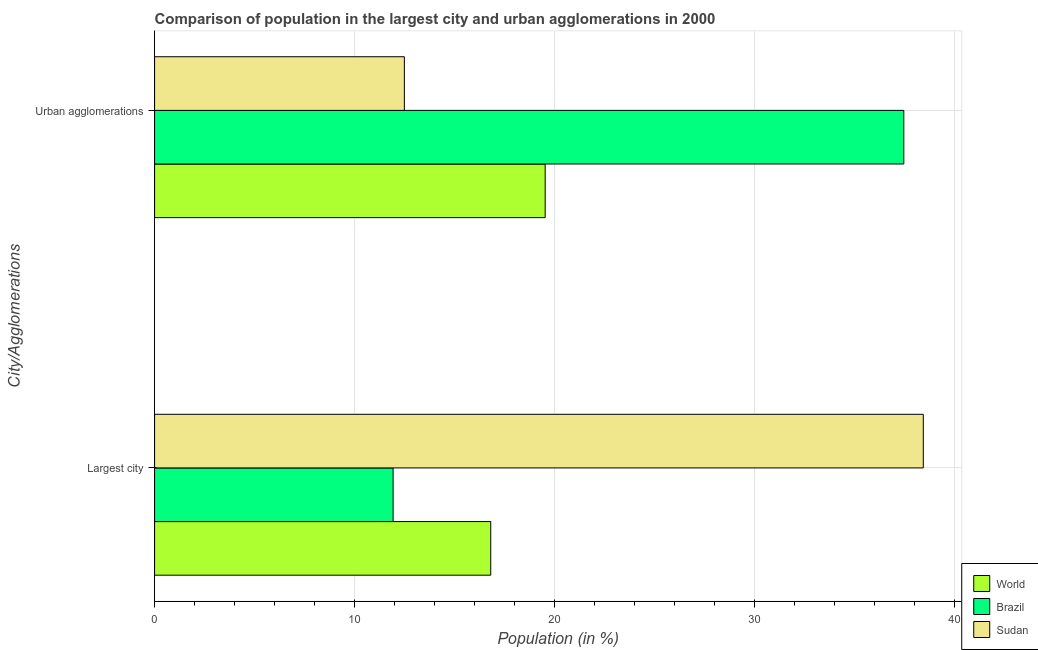How many different coloured bars are there?
Offer a terse response. 3. How many groups of bars are there?
Provide a succinct answer. 2. How many bars are there on the 2nd tick from the top?
Keep it short and to the point. 3. What is the label of the 1st group of bars from the top?
Ensure brevity in your answer.  Urban agglomerations. What is the population in the largest city in Sudan?
Provide a succinct answer. 38.42. Across all countries, what is the maximum population in the largest city?
Your response must be concise. 38.42. Across all countries, what is the minimum population in urban agglomerations?
Provide a short and direct response. 12.48. In which country was the population in urban agglomerations maximum?
Your answer should be compact. Brazil. In which country was the population in urban agglomerations minimum?
Your response must be concise. Sudan. What is the total population in the largest city in the graph?
Make the answer very short. 67.14. What is the difference between the population in urban agglomerations in Sudan and that in Brazil?
Offer a terse response. -24.96. What is the difference between the population in urban agglomerations in Sudan and the population in the largest city in World?
Make the answer very short. -4.32. What is the average population in urban agglomerations per country?
Offer a terse response. 23.15. What is the difference between the population in urban agglomerations and population in the largest city in Brazil?
Offer a terse response. 25.52. What is the ratio of the population in urban agglomerations in Sudan to that in World?
Make the answer very short. 0.64. In how many countries, is the population in urban agglomerations greater than the average population in urban agglomerations taken over all countries?
Your answer should be compact. 1. What does the 1st bar from the top in Urban agglomerations represents?
Your answer should be compact. Sudan. Are all the bars in the graph horizontal?
Your answer should be compact. Yes. What is the difference between two consecutive major ticks on the X-axis?
Provide a succinct answer. 10. Are the values on the major ticks of X-axis written in scientific E-notation?
Your answer should be very brief. No. Does the graph contain any zero values?
Give a very brief answer. No. Where does the legend appear in the graph?
Your response must be concise. Bottom right. How many legend labels are there?
Ensure brevity in your answer.  3. What is the title of the graph?
Offer a terse response. Comparison of population in the largest city and urban agglomerations in 2000. Does "Afghanistan" appear as one of the legend labels in the graph?
Offer a terse response. No. What is the label or title of the X-axis?
Ensure brevity in your answer.  Population (in %). What is the label or title of the Y-axis?
Offer a very short reply. City/Agglomerations. What is the Population (in %) in World in Largest city?
Provide a short and direct response. 16.8. What is the Population (in %) in Brazil in Largest city?
Give a very brief answer. 11.92. What is the Population (in %) in Sudan in Largest city?
Make the answer very short. 38.42. What is the Population (in %) in World in Urban agglomerations?
Your response must be concise. 19.52. What is the Population (in %) of Brazil in Urban agglomerations?
Provide a short and direct response. 37.44. What is the Population (in %) of Sudan in Urban agglomerations?
Your response must be concise. 12.48. Across all City/Agglomerations, what is the maximum Population (in %) of World?
Give a very brief answer. 19.52. Across all City/Agglomerations, what is the maximum Population (in %) of Brazil?
Provide a succinct answer. 37.44. Across all City/Agglomerations, what is the maximum Population (in %) in Sudan?
Your response must be concise. 38.42. Across all City/Agglomerations, what is the minimum Population (in %) of World?
Ensure brevity in your answer.  16.8. Across all City/Agglomerations, what is the minimum Population (in %) of Brazil?
Ensure brevity in your answer.  11.92. Across all City/Agglomerations, what is the minimum Population (in %) of Sudan?
Keep it short and to the point. 12.48. What is the total Population (in %) of World in the graph?
Offer a very short reply. 36.32. What is the total Population (in %) of Brazil in the graph?
Your response must be concise. 49.37. What is the total Population (in %) in Sudan in the graph?
Give a very brief answer. 50.9. What is the difference between the Population (in %) in World in Largest city and that in Urban agglomerations?
Keep it short and to the point. -2.72. What is the difference between the Population (in %) of Brazil in Largest city and that in Urban agglomerations?
Make the answer very short. -25.52. What is the difference between the Population (in %) of Sudan in Largest city and that in Urban agglomerations?
Offer a very short reply. 25.93. What is the difference between the Population (in %) of World in Largest city and the Population (in %) of Brazil in Urban agglomerations?
Offer a terse response. -20.64. What is the difference between the Population (in %) of World in Largest city and the Population (in %) of Sudan in Urban agglomerations?
Keep it short and to the point. 4.32. What is the difference between the Population (in %) in Brazil in Largest city and the Population (in %) in Sudan in Urban agglomerations?
Your answer should be very brief. -0.56. What is the average Population (in %) in World per City/Agglomerations?
Ensure brevity in your answer.  18.16. What is the average Population (in %) in Brazil per City/Agglomerations?
Keep it short and to the point. 24.68. What is the average Population (in %) in Sudan per City/Agglomerations?
Give a very brief answer. 25.45. What is the difference between the Population (in %) of World and Population (in %) of Brazil in Largest city?
Your answer should be very brief. 4.88. What is the difference between the Population (in %) in World and Population (in %) in Sudan in Largest city?
Offer a very short reply. -21.62. What is the difference between the Population (in %) of Brazil and Population (in %) of Sudan in Largest city?
Give a very brief answer. -26.5. What is the difference between the Population (in %) of World and Population (in %) of Brazil in Urban agglomerations?
Give a very brief answer. -17.92. What is the difference between the Population (in %) of World and Population (in %) of Sudan in Urban agglomerations?
Keep it short and to the point. 7.04. What is the difference between the Population (in %) of Brazil and Population (in %) of Sudan in Urban agglomerations?
Your answer should be very brief. 24.96. What is the ratio of the Population (in %) in World in Largest city to that in Urban agglomerations?
Give a very brief answer. 0.86. What is the ratio of the Population (in %) in Brazil in Largest city to that in Urban agglomerations?
Make the answer very short. 0.32. What is the ratio of the Population (in %) in Sudan in Largest city to that in Urban agglomerations?
Offer a terse response. 3.08. What is the difference between the highest and the second highest Population (in %) in World?
Your answer should be compact. 2.72. What is the difference between the highest and the second highest Population (in %) of Brazil?
Ensure brevity in your answer.  25.52. What is the difference between the highest and the second highest Population (in %) of Sudan?
Provide a succinct answer. 25.93. What is the difference between the highest and the lowest Population (in %) of World?
Ensure brevity in your answer.  2.72. What is the difference between the highest and the lowest Population (in %) of Brazil?
Make the answer very short. 25.52. What is the difference between the highest and the lowest Population (in %) in Sudan?
Make the answer very short. 25.93. 